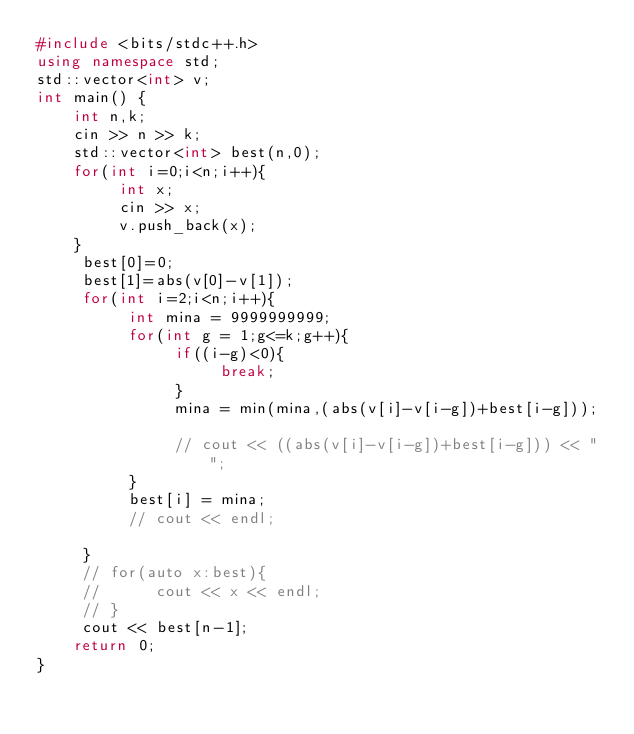<code> <loc_0><loc_0><loc_500><loc_500><_C++_>#include <bits/stdc++.h>
using namespace std;
std::vector<int> v;
int main() {
	int n,k;
	cin >> n >> k;
	std::vector<int> best(n,0);
	for(int i=0;i<n;i++){
	     int x;
	     cin >> x;
	     v.push_back(x);
	}
     best[0]=0;
     best[1]=abs(v[0]-v[1]);
     for(int i=2;i<n;i++){
          int mina = 9999999999;
          for(int g = 1;g<=k;g++){
               if((i-g)<0){
                    break;
               }
               mina = min(mina,(abs(v[i]-v[i-g])+best[i-g]));
               
               // cout << ((abs(v[i]-v[i-g])+best[i-g])) << " ";
          }
          best[i] = mina;
          // cout << endl;
          
     }
     // for(auto x:best){
     //      cout << x << endl;
     // }
     cout << best[n-1];
	return 0;
}
</code> 